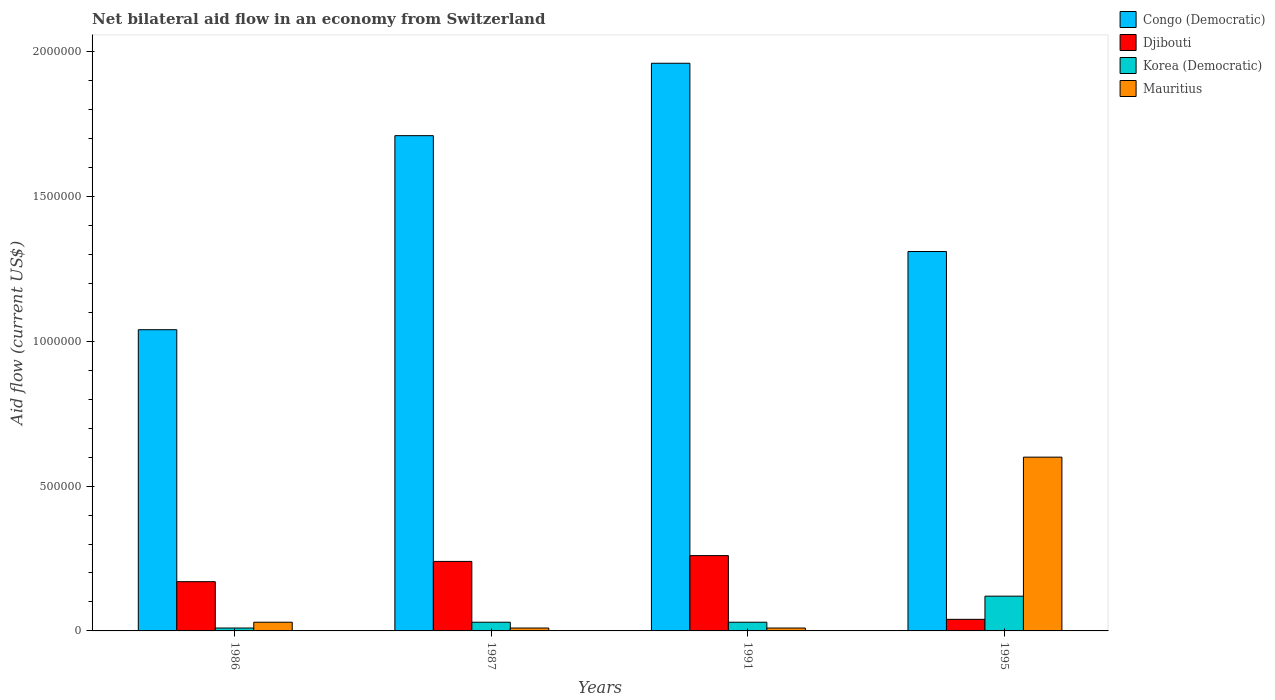How many groups of bars are there?
Your answer should be very brief. 4. Are the number of bars per tick equal to the number of legend labels?
Keep it short and to the point. Yes. How many bars are there on the 3rd tick from the right?
Keep it short and to the point. 4. What is the label of the 1st group of bars from the left?
Offer a very short reply. 1986. What is the net bilateral aid flow in Mauritius in 1995?
Offer a very short reply. 6.00e+05. Across all years, what is the maximum net bilateral aid flow in Djibouti?
Your response must be concise. 2.60e+05. Across all years, what is the minimum net bilateral aid flow in Korea (Democratic)?
Your answer should be very brief. 10000. In which year was the net bilateral aid flow in Djibouti minimum?
Offer a terse response. 1995. What is the total net bilateral aid flow in Mauritius in the graph?
Offer a terse response. 6.50e+05. What is the difference between the net bilateral aid flow in Mauritius in 1987 and that in 1995?
Give a very brief answer. -5.90e+05. What is the difference between the net bilateral aid flow in Djibouti in 1987 and the net bilateral aid flow in Congo (Democratic) in 1991?
Keep it short and to the point. -1.72e+06. What is the average net bilateral aid flow in Mauritius per year?
Ensure brevity in your answer.  1.62e+05. In the year 1995, what is the difference between the net bilateral aid flow in Congo (Democratic) and net bilateral aid flow in Djibouti?
Your answer should be compact. 1.27e+06. In how many years, is the net bilateral aid flow in Djibouti greater than 700000 US$?
Keep it short and to the point. 0. What is the ratio of the net bilateral aid flow in Djibouti in 1987 to that in 1991?
Give a very brief answer. 0.92. Is the net bilateral aid flow in Korea (Democratic) in 1986 less than that in 1987?
Offer a very short reply. Yes. Is the difference between the net bilateral aid flow in Congo (Democratic) in 1991 and 1995 greater than the difference between the net bilateral aid flow in Djibouti in 1991 and 1995?
Offer a terse response. Yes. What is the difference between the highest and the second highest net bilateral aid flow in Korea (Democratic)?
Ensure brevity in your answer.  9.00e+04. What is the difference between the highest and the lowest net bilateral aid flow in Mauritius?
Give a very brief answer. 5.90e+05. In how many years, is the net bilateral aid flow in Congo (Democratic) greater than the average net bilateral aid flow in Congo (Democratic) taken over all years?
Ensure brevity in your answer.  2. Is the sum of the net bilateral aid flow in Congo (Democratic) in 1986 and 1995 greater than the maximum net bilateral aid flow in Mauritius across all years?
Keep it short and to the point. Yes. What does the 1st bar from the left in 1986 represents?
Keep it short and to the point. Congo (Democratic). What does the 3rd bar from the right in 1986 represents?
Your answer should be very brief. Djibouti. Is it the case that in every year, the sum of the net bilateral aid flow in Congo (Democratic) and net bilateral aid flow in Djibouti is greater than the net bilateral aid flow in Korea (Democratic)?
Give a very brief answer. Yes. How many years are there in the graph?
Offer a very short reply. 4. Are the values on the major ticks of Y-axis written in scientific E-notation?
Provide a short and direct response. No. How many legend labels are there?
Your response must be concise. 4. What is the title of the graph?
Make the answer very short. Net bilateral aid flow in an economy from Switzerland. Does "New Zealand" appear as one of the legend labels in the graph?
Ensure brevity in your answer.  No. What is the label or title of the X-axis?
Provide a short and direct response. Years. What is the label or title of the Y-axis?
Your response must be concise. Aid flow (current US$). What is the Aid flow (current US$) in Congo (Democratic) in 1986?
Your answer should be compact. 1.04e+06. What is the Aid flow (current US$) in Djibouti in 1986?
Keep it short and to the point. 1.70e+05. What is the Aid flow (current US$) of Korea (Democratic) in 1986?
Ensure brevity in your answer.  10000. What is the Aid flow (current US$) in Mauritius in 1986?
Provide a short and direct response. 3.00e+04. What is the Aid flow (current US$) in Congo (Democratic) in 1987?
Offer a very short reply. 1.71e+06. What is the Aid flow (current US$) in Mauritius in 1987?
Keep it short and to the point. 10000. What is the Aid flow (current US$) in Congo (Democratic) in 1991?
Give a very brief answer. 1.96e+06. What is the Aid flow (current US$) in Djibouti in 1991?
Ensure brevity in your answer.  2.60e+05. What is the Aid flow (current US$) of Mauritius in 1991?
Offer a very short reply. 10000. What is the Aid flow (current US$) of Congo (Democratic) in 1995?
Ensure brevity in your answer.  1.31e+06. What is the Aid flow (current US$) in Mauritius in 1995?
Provide a short and direct response. 6.00e+05. Across all years, what is the maximum Aid flow (current US$) of Congo (Democratic)?
Make the answer very short. 1.96e+06. Across all years, what is the maximum Aid flow (current US$) of Djibouti?
Give a very brief answer. 2.60e+05. Across all years, what is the minimum Aid flow (current US$) in Congo (Democratic)?
Your answer should be very brief. 1.04e+06. Across all years, what is the minimum Aid flow (current US$) of Mauritius?
Provide a short and direct response. 10000. What is the total Aid flow (current US$) of Congo (Democratic) in the graph?
Offer a very short reply. 6.02e+06. What is the total Aid flow (current US$) of Djibouti in the graph?
Provide a succinct answer. 7.10e+05. What is the total Aid flow (current US$) in Korea (Democratic) in the graph?
Offer a terse response. 1.90e+05. What is the total Aid flow (current US$) in Mauritius in the graph?
Provide a short and direct response. 6.50e+05. What is the difference between the Aid flow (current US$) of Congo (Democratic) in 1986 and that in 1987?
Keep it short and to the point. -6.70e+05. What is the difference between the Aid flow (current US$) of Djibouti in 1986 and that in 1987?
Offer a very short reply. -7.00e+04. What is the difference between the Aid flow (current US$) of Mauritius in 1986 and that in 1987?
Provide a succinct answer. 2.00e+04. What is the difference between the Aid flow (current US$) of Congo (Democratic) in 1986 and that in 1991?
Offer a terse response. -9.20e+05. What is the difference between the Aid flow (current US$) of Djibouti in 1986 and that in 1991?
Provide a succinct answer. -9.00e+04. What is the difference between the Aid flow (current US$) in Korea (Democratic) in 1986 and that in 1991?
Provide a short and direct response. -2.00e+04. What is the difference between the Aid flow (current US$) of Congo (Democratic) in 1986 and that in 1995?
Offer a terse response. -2.70e+05. What is the difference between the Aid flow (current US$) of Djibouti in 1986 and that in 1995?
Give a very brief answer. 1.30e+05. What is the difference between the Aid flow (current US$) in Korea (Democratic) in 1986 and that in 1995?
Make the answer very short. -1.10e+05. What is the difference between the Aid flow (current US$) in Mauritius in 1986 and that in 1995?
Ensure brevity in your answer.  -5.70e+05. What is the difference between the Aid flow (current US$) in Congo (Democratic) in 1987 and that in 1991?
Ensure brevity in your answer.  -2.50e+05. What is the difference between the Aid flow (current US$) in Mauritius in 1987 and that in 1991?
Your answer should be very brief. 0. What is the difference between the Aid flow (current US$) of Congo (Democratic) in 1987 and that in 1995?
Offer a terse response. 4.00e+05. What is the difference between the Aid flow (current US$) in Djibouti in 1987 and that in 1995?
Offer a very short reply. 2.00e+05. What is the difference between the Aid flow (current US$) in Mauritius in 1987 and that in 1995?
Offer a very short reply. -5.90e+05. What is the difference between the Aid flow (current US$) of Congo (Democratic) in 1991 and that in 1995?
Offer a very short reply. 6.50e+05. What is the difference between the Aid flow (current US$) in Djibouti in 1991 and that in 1995?
Your answer should be compact. 2.20e+05. What is the difference between the Aid flow (current US$) of Mauritius in 1991 and that in 1995?
Your answer should be compact. -5.90e+05. What is the difference between the Aid flow (current US$) in Congo (Democratic) in 1986 and the Aid flow (current US$) in Djibouti in 1987?
Ensure brevity in your answer.  8.00e+05. What is the difference between the Aid flow (current US$) of Congo (Democratic) in 1986 and the Aid flow (current US$) of Korea (Democratic) in 1987?
Ensure brevity in your answer.  1.01e+06. What is the difference between the Aid flow (current US$) of Congo (Democratic) in 1986 and the Aid flow (current US$) of Mauritius in 1987?
Offer a terse response. 1.03e+06. What is the difference between the Aid flow (current US$) in Djibouti in 1986 and the Aid flow (current US$) in Korea (Democratic) in 1987?
Your answer should be very brief. 1.40e+05. What is the difference between the Aid flow (current US$) in Korea (Democratic) in 1986 and the Aid flow (current US$) in Mauritius in 1987?
Offer a very short reply. 0. What is the difference between the Aid flow (current US$) of Congo (Democratic) in 1986 and the Aid flow (current US$) of Djibouti in 1991?
Provide a short and direct response. 7.80e+05. What is the difference between the Aid flow (current US$) of Congo (Democratic) in 1986 and the Aid flow (current US$) of Korea (Democratic) in 1991?
Give a very brief answer. 1.01e+06. What is the difference between the Aid flow (current US$) of Congo (Democratic) in 1986 and the Aid flow (current US$) of Mauritius in 1991?
Provide a succinct answer. 1.03e+06. What is the difference between the Aid flow (current US$) in Korea (Democratic) in 1986 and the Aid flow (current US$) in Mauritius in 1991?
Offer a very short reply. 0. What is the difference between the Aid flow (current US$) of Congo (Democratic) in 1986 and the Aid flow (current US$) of Korea (Democratic) in 1995?
Your answer should be very brief. 9.20e+05. What is the difference between the Aid flow (current US$) in Congo (Democratic) in 1986 and the Aid flow (current US$) in Mauritius in 1995?
Keep it short and to the point. 4.40e+05. What is the difference between the Aid flow (current US$) in Djibouti in 1986 and the Aid flow (current US$) in Korea (Democratic) in 1995?
Give a very brief answer. 5.00e+04. What is the difference between the Aid flow (current US$) of Djibouti in 1986 and the Aid flow (current US$) of Mauritius in 1995?
Provide a succinct answer. -4.30e+05. What is the difference between the Aid flow (current US$) in Korea (Democratic) in 1986 and the Aid flow (current US$) in Mauritius in 1995?
Provide a short and direct response. -5.90e+05. What is the difference between the Aid flow (current US$) in Congo (Democratic) in 1987 and the Aid flow (current US$) in Djibouti in 1991?
Provide a short and direct response. 1.45e+06. What is the difference between the Aid flow (current US$) of Congo (Democratic) in 1987 and the Aid flow (current US$) of Korea (Democratic) in 1991?
Keep it short and to the point. 1.68e+06. What is the difference between the Aid flow (current US$) in Congo (Democratic) in 1987 and the Aid flow (current US$) in Mauritius in 1991?
Provide a short and direct response. 1.70e+06. What is the difference between the Aid flow (current US$) in Djibouti in 1987 and the Aid flow (current US$) in Korea (Democratic) in 1991?
Give a very brief answer. 2.10e+05. What is the difference between the Aid flow (current US$) in Djibouti in 1987 and the Aid flow (current US$) in Mauritius in 1991?
Provide a short and direct response. 2.30e+05. What is the difference between the Aid flow (current US$) in Korea (Democratic) in 1987 and the Aid flow (current US$) in Mauritius in 1991?
Provide a succinct answer. 2.00e+04. What is the difference between the Aid flow (current US$) in Congo (Democratic) in 1987 and the Aid flow (current US$) in Djibouti in 1995?
Ensure brevity in your answer.  1.67e+06. What is the difference between the Aid flow (current US$) in Congo (Democratic) in 1987 and the Aid flow (current US$) in Korea (Democratic) in 1995?
Offer a very short reply. 1.59e+06. What is the difference between the Aid flow (current US$) of Congo (Democratic) in 1987 and the Aid flow (current US$) of Mauritius in 1995?
Provide a succinct answer. 1.11e+06. What is the difference between the Aid flow (current US$) of Djibouti in 1987 and the Aid flow (current US$) of Korea (Democratic) in 1995?
Give a very brief answer. 1.20e+05. What is the difference between the Aid flow (current US$) in Djibouti in 1987 and the Aid flow (current US$) in Mauritius in 1995?
Make the answer very short. -3.60e+05. What is the difference between the Aid flow (current US$) in Korea (Democratic) in 1987 and the Aid flow (current US$) in Mauritius in 1995?
Keep it short and to the point. -5.70e+05. What is the difference between the Aid flow (current US$) in Congo (Democratic) in 1991 and the Aid flow (current US$) in Djibouti in 1995?
Your response must be concise. 1.92e+06. What is the difference between the Aid flow (current US$) of Congo (Democratic) in 1991 and the Aid flow (current US$) of Korea (Democratic) in 1995?
Keep it short and to the point. 1.84e+06. What is the difference between the Aid flow (current US$) of Congo (Democratic) in 1991 and the Aid flow (current US$) of Mauritius in 1995?
Ensure brevity in your answer.  1.36e+06. What is the difference between the Aid flow (current US$) in Korea (Democratic) in 1991 and the Aid flow (current US$) in Mauritius in 1995?
Offer a very short reply. -5.70e+05. What is the average Aid flow (current US$) in Congo (Democratic) per year?
Ensure brevity in your answer.  1.50e+06. What is the average Aid flow (current US$) in Djibouti per year?
Provide a succinct answer. 1.78e+05. What is the average Aid flow (current US$) of Korea (Democratic) per year?
Provide a succinct answer. 4.75e+04. What is the average Aid flow (current US$) of Mauritius per year?
Keep it short and to the point. 1.62e+05. In the year 1986, what is the difference between the Aid flow (current US$) of Congo (Democratic) and Aid flow (current US$) of Djibouti?
Provide a short and direct response. 8.70e+05. In the year 1986, what is the difference between the Aid flow (current US$) in Congo (Democratic) and Aid flow (current US$) in Korea (Democratic)?
Offer a very short reply. 1.03e+06. In the year 1986, what is the difference between the Aid flow (current US$) in Congo (Democratic) and Aid flow (current US$) in Mauritius?
Provide a short and direct response. 1.01e+06. In the year 1986, what is the difference between the Aid flow (current US$) in Djibouti and Aid flow (current US$) in Korea (Democratic)?
Keep it short and to the point. 1.60e+05. In the year 1987, what is the difference between the Aid flow (current US$) of Congo (Democratic) and Aid flow (current US$) of Djibouti?
Ensure brevity in your answer.  1.47e+06. In the year 1987, what is the difference between the Aid flow (current US$) in Congo (Democratic) and Aid flow (current US$) in Korea (Democratic)?
Provide a succinct answer. 1.68e+06. In the year 1987, what is the difference between the Aid flow (current US$) of Congo (Democratic) and Aid flow (current US$) of Mauritius?
Offer a terse response. 1.70e+06. In the year 1987, what is the difference between the Aid flow (current US$) in Djibouti and Aid flow (current US$) in Korea (Democratic)?
Offer a very short reply. 2.10e+05. In the year 1987, what is the difference between the Aid flow (current US$) in Korea (Democratic) and Aid flow (current US$) in Mauritius?
Your answer should be very brief. 2.00e+04. In the year 1991, what is the difference between the Aid flow (current US$) in Congo (Democratic) and Aid flow (current US$) in Djibouti?
Offer a terse response. 1.70e+06. In the year 1991, what is the difference between the Aid flow (current US$) in Congo (Democratic) and Aid flow (current US$) in Korea (Democratic)?
Your answer should be very brief. 1.93e+06. In the year 1991, what is the difference between the Aid flow (current US$) in Congo (Democratic) and Aid flow (current US$) in Mauritius?
Provide a short and direct response. 1.95e+06. In the year 1991, what is the difference between the Aid flow (current US$) in Djibouti and Aid flow (current US$) in Korea (Democratic)?
Provide a succinct answer. 2.30e+05. In the year 1991, what is the difference between the Aid flow (current US$) of Korea (Democratic) and Aid flow (current US$) of Mauritius?
Your response must be concise. 2.00e+04. In the year 1995, what is the difference between the Aid flow (current US$) of Congo (Democratic) and Aid flow (current US$) of Djibouti?
Provide a succinct answer. 1.27e+06. In the year 1995, what is the difference between the Aid flow (current US$) in Congo (Democratic) and Aid flow (current US$) in Korea (Democratic)?
Keep it short and to the point. 1.19e+06. In the year 1995, what is the difference between the Aid flow (current US$) of Congo (Democratic) and Aid flow (current US$) of Mauritius?
Provide a succinct answer. 7.10e+05. In the year 1995, what is the difference between the Aid flow (current US$) in Djibouti and Aid flow (current US$) in Mauritius?
Ensure brevity in your answer.  -5.60e+05. In the year 1995, what is the difference between the Aid flow (current US$) of Korea (Democratic) and Aid flow (current US$) of Mauritius?
Your answer should be compact. -4.80e+05. What is the ratio of the Aid flow (current US$) of Congo (Democratic) in 1986 to that in 1987?
Your answer should be very brief. 0.61. What is the ratio of the Aid flow (current US$) of Djibouti in 1986 to that in 1987?
Give a very brief answer. 0.71. What is the ratio of the Aid flow (current US$) in Korea (Democratic) in 1986 to that in 1987?
Provide a succinct answer. 0.33. What is the ratio of the Aid flow (current US$) of Mauritius in 1986 to that in 1987?
Provide a short and direct response. 3. What is the ratio of the Aid flow (current US$) in Congo (Democratic) in 1986 to that in 1991?
Ensure brevity in your answer.  0.53. What is the ratio of the Aid flow (current US$) in Djibouti in 1986 to that in 1991?
Offer a very short reply. 0.65. What is the ratio of the Aid flow (current US$) of Korea (Democratic) in 1986 to that in 1991?
Keep it short and to the point. 0.33. What is the ratio of the Aid flow (current US$) of Congo (Democratic) in 1986 to that in 1995?
Your response must be concise. 0.79. What is the ratio of the Aid flow (current US$) in Djibouti in 1986 to that in 1995?
Offer a terse response. 4.25. What is the ratio of the Aid flow (current US$) in Korea (Democratic) in 1986 to that in 1995?
Offer a terse response. 0.08. What is the ratio of the Aid flow (current US$) in Mauritius in 1986 to that in 1995?
Provide a short and direct response. 0.05. What is the ratio of the Aid flow (current US$) of Congo (Democratic) in 1987 to that in 1991?
Ensure brevity in your answer.  0.87. What is the ratio of the Aid flow (current US$) of Mauritius in 1987 to that in 1991?
Provide a succinct answer. 1. What is the ratio of the Aid flow (current US$) of Congo (Democratic) in 1987 to that in 1995?
Your answer should be very brief. 1.31. What is the ratio of the Aid flow (current US$) in Djibouti in 1987 to that in 1995?
Offer a very short reply. 6. What is the ratio of the Aid flow (current US$) of Korea (Democratic) in 1987 to that in 1995?
Your answer should be compact. 0.25. What is the ratio of the Aid flow (current US$) of Mauritius in 1987 to that in 1995?
Keep it short and to the point. 0.02. What is the ratio of the Aid flow (current US$) of Congo (Democratic) in 1991 to that in 1995?
Offer a terse response. 1.5. What is the ratio of the Aid flow (current US$) of Djibouti in 1991 to that in 1995?
Keep it short and to the point. 6.5. What is the ratio of the Aid flow (current US$) in Korea (Democratic) in 1991 to that in 1995?
Ensure brevity in your answer.  0.25. What is the ratio of the Aid flow (current US$) in Mauritius in 1991 to that in 1995?
Offer a terse response. 0.02. What is the difference between the highest and the second highest Aid flow (current US$) in Congo (Democratic)?
Provide a succinct answer. 2.50e+05. What is the difference between the highest and the second highest Aid flow (current US$) in Djibouti?
Keep it short and to the point. 2.00e+04. What is the difference between the highest and the second highest Aid flow (current US$) in Korea (Democratic)?
Your answer should be very brief. 9.00e+04. What is the difference between the highest and the second highest Aid flow (current US$) of Mauritius?
Make the answer very short. 5.70e+05. What is the difference between the highest and the lowest Aid flow (current US$) of Congo (Democratic)?
Offer a terse response. 9.20e+05. What is the difference between the highest and the lowest Aid flow (current US$) of Djibouti?
Keep it short and to the point. 2.20e+05. What is the difference between the highest and the lowest Aid flow (current US$) in Korea (Democratic)?
Offer a very short reply. 1.10e+05. What is the difference between the highest and the lowest Aid flow (current US$) in Mauritius?
Offer a terse response. 5.90e+05. 